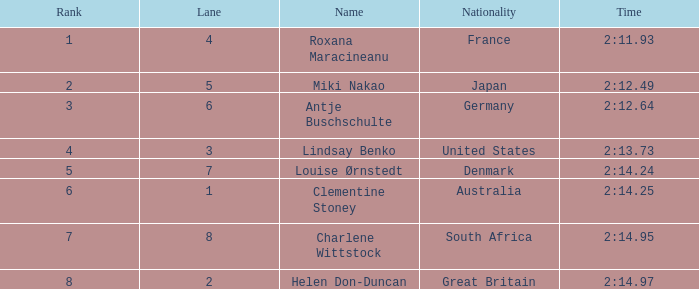What displays for nationality when there is a rank higher than 6, and a time of 2:1 South Africa. Help me parse the entirety of this table. {'header': ['Rank', 'Lane', 'Name', 'Nationality', 'Time'], 'rows': [['1', '4', 'Roxana Maracineanu', 'France', '2:11.93'], ['2', '5', 'Miki Nakao', 'Japan', '2:12.49'], ['3', '6', 'Antje Buschschulte', 'Germany', '2:12.64'], ['4', '3', 'Lindsay Benko', 'United States', '2:13.73'], ['5', '7', 'Louise Ørnstedt', 'Denmark', '2:14.24'], ['6', '1', 'Clementine Stoney', 'Australia', '2:14.25'], ['7', '8', 'Charlene Wittstock', 'South Africa', '2:14.95'], ['8', '2', 'Helen Don-Duncan', 'Great Britain', '2:14.97']]} 